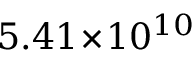Convert formula to latex. <formula><loc_0><loc_0><loc_500><loc_500>5 . 4 1 \, \times \, 1 0 ^ { 1 0 }</formula> 